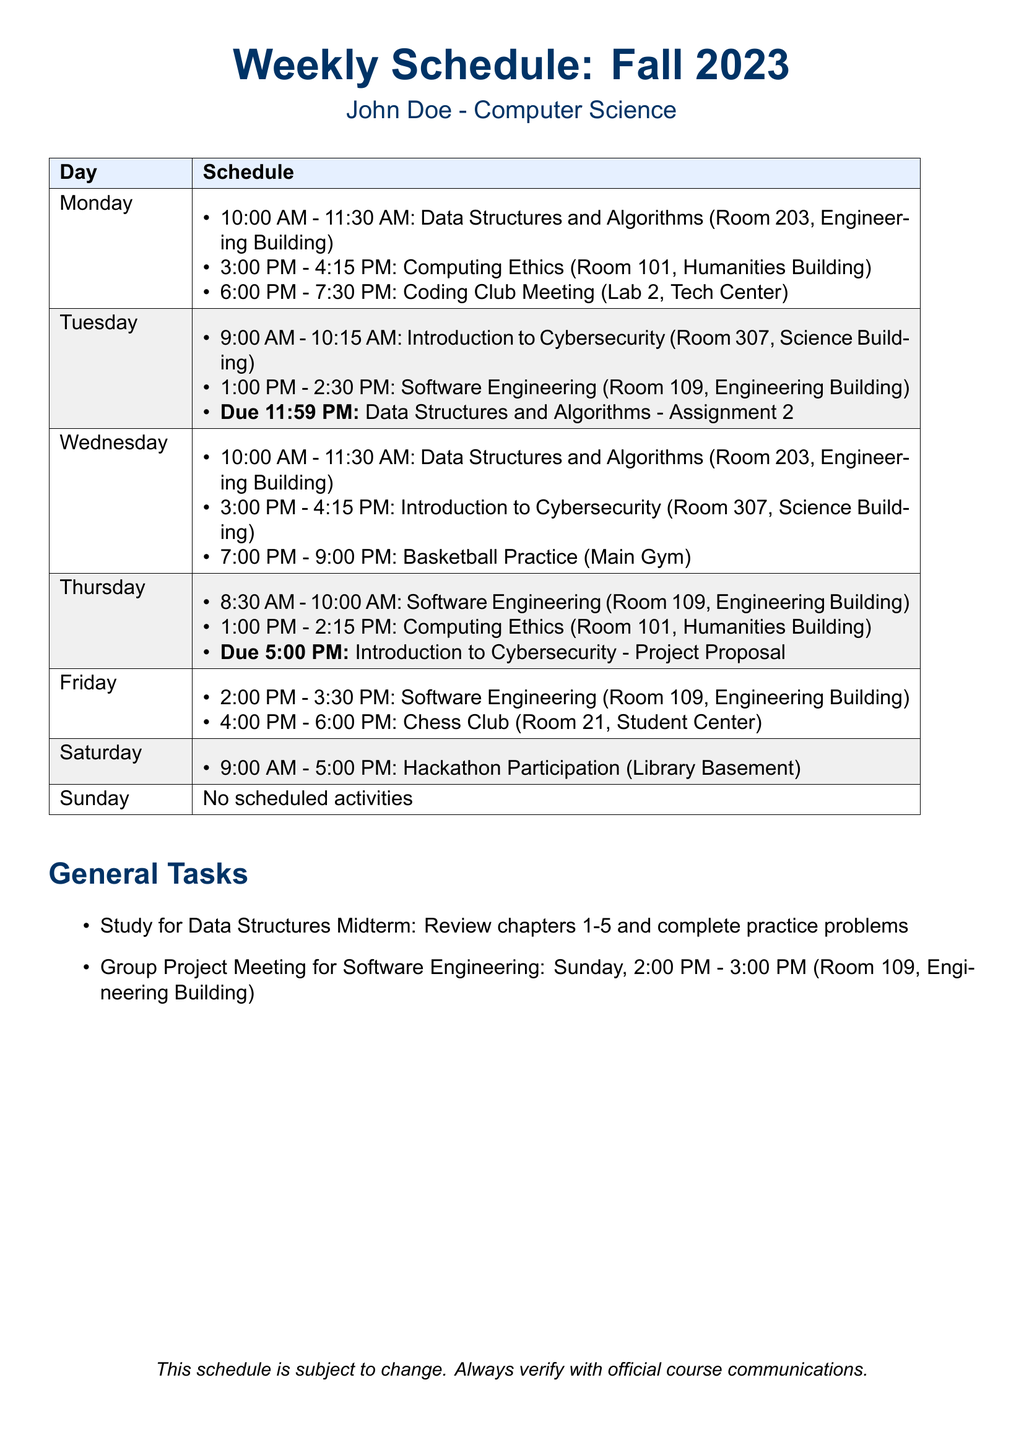What is the time for Data Structures and Algorithms on Monday? The schedule shows that Data Structures and Algorithms is from 10:00 AM to 11:30 AM on Monday.
Answer: 10:00 AM - 11:30 AM When is the assignment for Data Structures and Algorithms due? According to the schedule, the due date for Assignment 2 is at 11:59 PM on Tuesday.
Answer: 11:59 PM Tuesday How many extracurricular activities are scheduled on Friday? The schedule lists two activities on Friday: Software Engineering class and Chess Club.
Answer: 2 Which room is the Computing Ethics class held in on Thursday? The schedule specifies that the Computing Ethics class is in Room 101 on Thursday.
Answer: Room 101 What day is the Hackathon Participation scheduled? The schedule indicates that Hackathon Participation is on Saturday.
Answer: Saturday What are the general tasks listed in the document? The general tasks include studying for the Data Structures Midterm and a Group Project Meeting for Software Engineering.
Answer: Study for Data Structures Midterm and Group Project Meeting What is the last activity scheduled for the week? According to the document, the last activity is on Sunday, which has no scheduled activities.
Answer: No scheduled activities Which class starts earliest in the week? The earliest class listed in the schedule is Introduction to Cybersecurity on Tuesday at 9:00 AM.
Answer: Introduction to Cybersecurity What is the time for Basketball Practice on Wednesday? The document states that Basketball Practice is from 7:00 PM to 9:00 PM on Wednesday.
Answer: 7:00 PM - 9:00 PM 